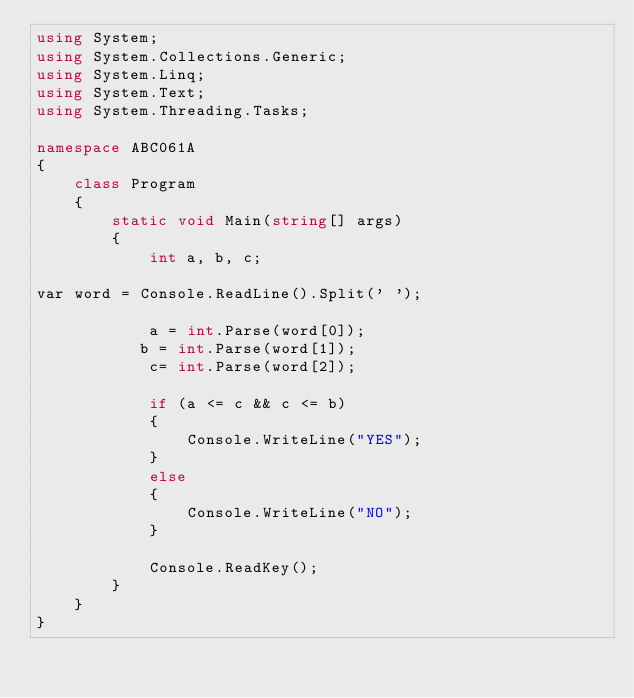Convert code to text. <code><loc_0><loc_0><loc_500><loc_500><_C#_>using System;
using System.Collections.Generic;
using System.Linq;
using System.Text;
using System.Threading.Tasks;

namespace ABC061A
{
    class Program
    {
        static void Main(string[] args)
        {
            int a, b, c;

var word = Console.ReadLine().Split(' ');

            a = int.Parse(word[0]);
           b = int.Parse(word[1]);
            c= int.Parse(word[2]);

            if (a <= c && c <= b)
            {
                Console.WriteLine("YES");
            }
            else
            {
                Console.WriteLine("NO");
            }

            Console.ReadKey();
        }
    }
}</code> 